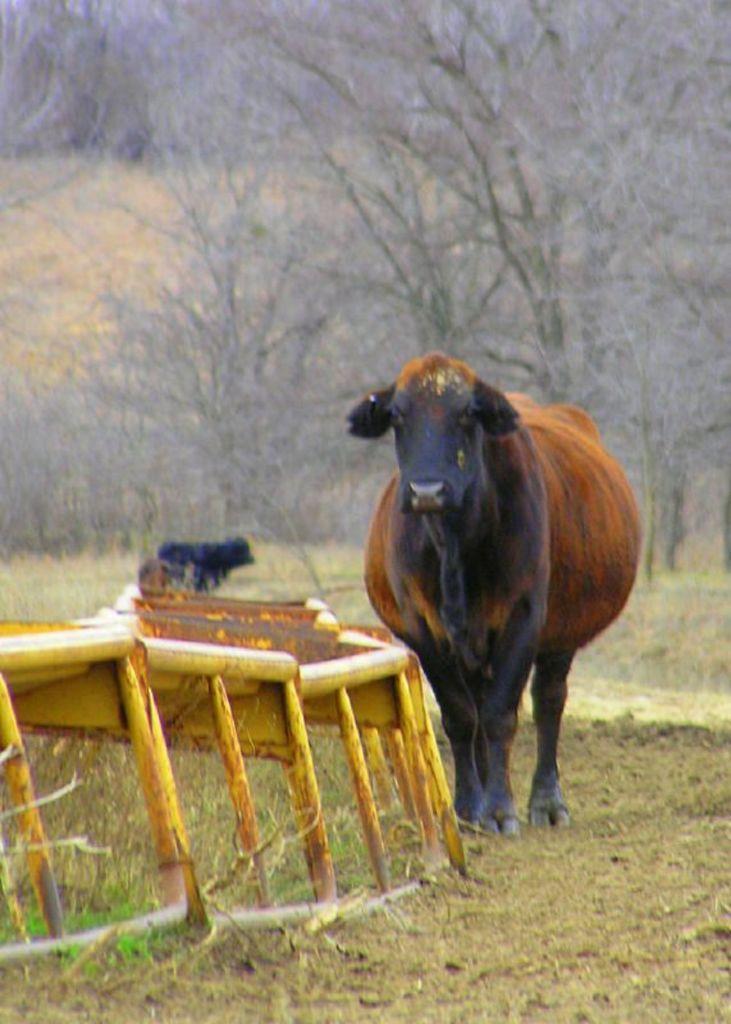Please provide a concise description of this image. In the image we can see there are cows standing on the ground and the ground is covered with grass. Beside there is an iron rods object and there are lot of trees at the back. 